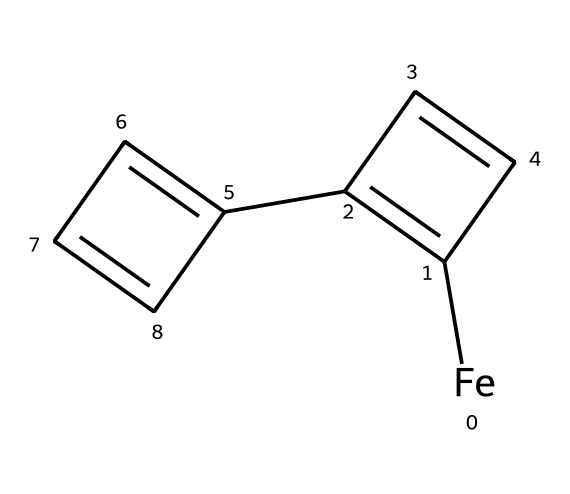What is the central metal in ferrocene? The SMILES representation indicates that the compound contains an iron atom, which is represented by "[Fe]" in the structure. This signifies that iron is the central metal coordinating with the cyclopentadienyl rings.
Answer: iron How many carbon atoms are there in ferrocene? The structure reveals there are two cyclopentadienyl rings, each containing five carbon atoms, leading to a total of ten carbon atoms in the entire molecule (5 C from one ring + 5 C from the other ring).
Answer: ten What type of bonding mainly occurs between iron and the cyclopentadienyl rings in ferrocene? In the given structure, the bond between the iron atom and the cyclopentadienyl rings involves coordinate covalent bonding, where the cyclopentadienyl anions donate electron pairs to the iron.
Answer: coordinate covalent How many π-electrons are delocalized in ferrocene? Each cyclopentadienyl ring contributes six π-electrons, and since there are two rings, the total number of delocalized π-electrons in ferrocene is 10 (due to the resonance stabilization).
Answer: ten Is ferrocene considered a stable organometallic compound? Ferrocene is known for its stability in ambient conditions due to its symmetrical structure and strong iron-carbon bonds, which give it a characteristic resistance to oxidation.
Answer: yes What are the main functional groups present in ferrocene? The main functional groups are the cyclopentadienyl rings, as they contain the carbon skeleton contributing to the organometallic characteristics, while the central iron acts to bond to these groups.
Answer: cyclopentadienyl rings 